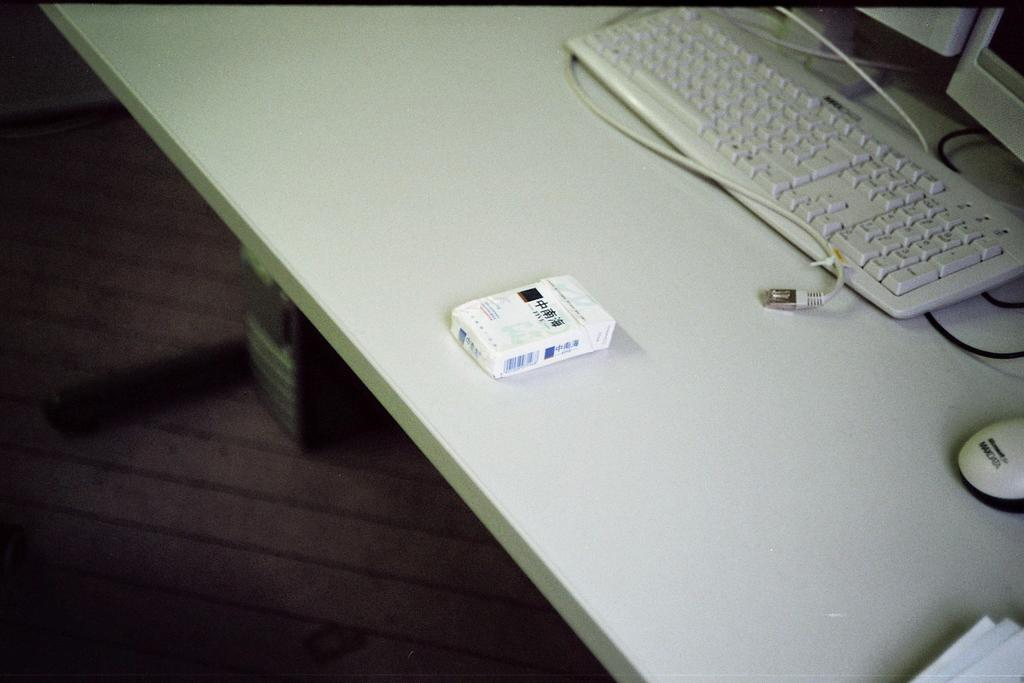<image>
Describe the image concisely. a white desk with white keyboard and mouse reading Max Data 